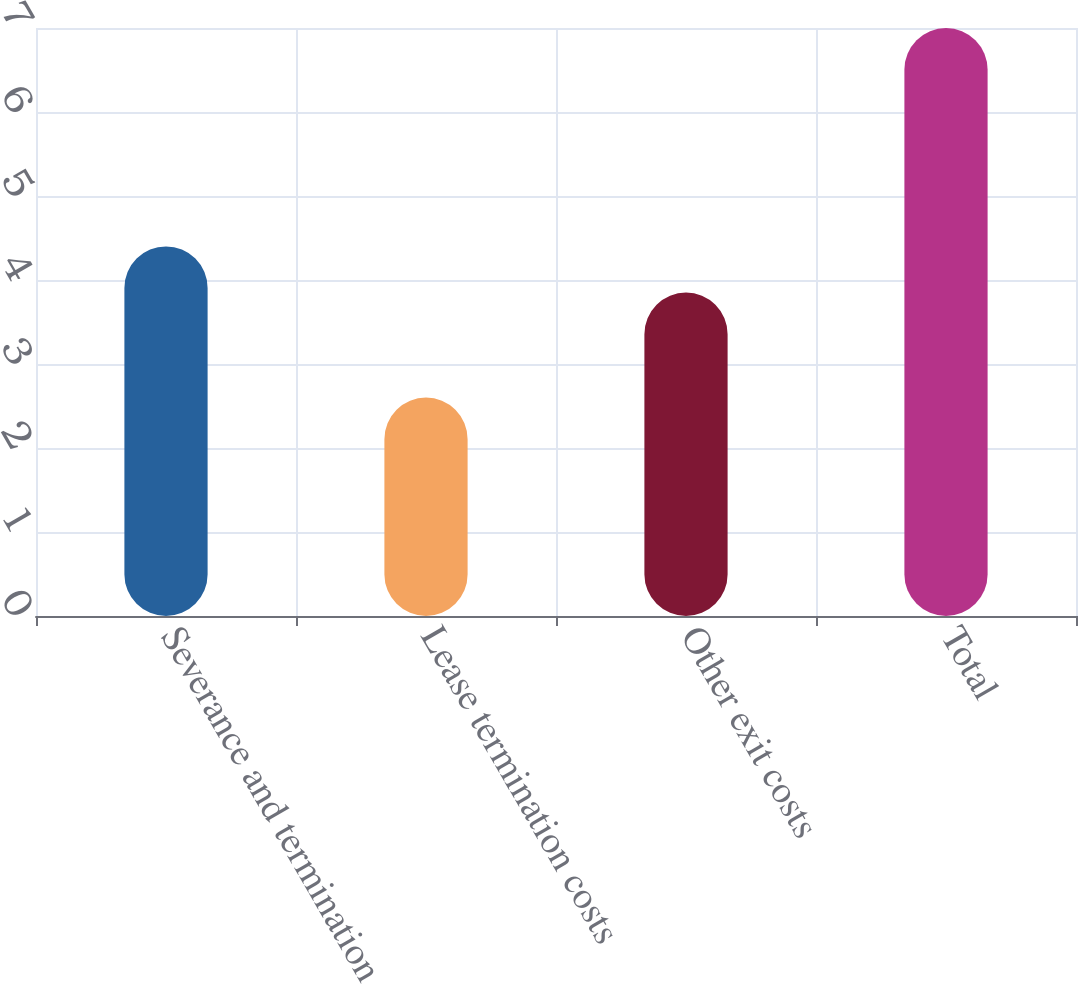Convert chart to OTSL. <chart><loc_0><loc_0><loc_500><loc_500><bar_chart><fcel>Severance and termination<fcel>Lease termination costs<fcel>Other exit costs<fcel>Total<nl><fcel>4.4<fcel>2.6<fcel>3.85<fcel>7<nl></chart> 